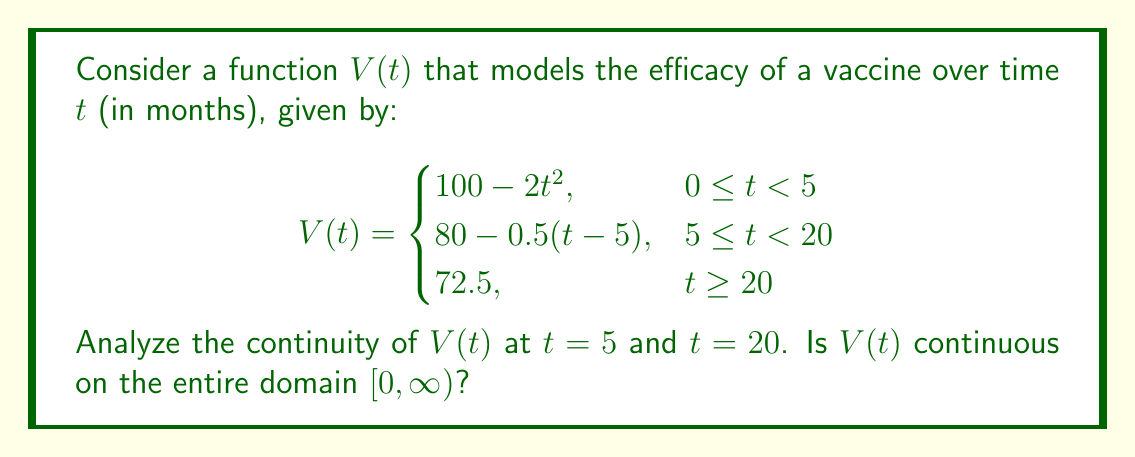Show me your answer to this math problem. To analyze the continuity of $V(t)$, we need to check for continuity at the points where the function definition changes: $t = 5$ and $t = 20$. We'll also need to consider the continuity within each piece of the function.

1. Continuity at $t = 5$:
   To be continuous at $t = 5$, we need:
   $\lim_{t \to 5^-} V(t) = \lim_{t \to 5^+} V(t) = V(5)$

   Left-hand limit: $\lim_{t \to 5^-} V(t) = 100 - 2(5)^2 = 50$
   Right-hand limit: $\lim_{t \to 5^+} V(t) = 80 - 0.5(5-5) = 80$
   Function value: $V(5) = 80 - 0.5(5-5) = 80$

   The left-hand limit doesn't equal the right-hand limit, so $V(t)$ is not continuous at $t = 5$.

2. Continuity at $t = 20$:
   Left-hand limit: $\lim_{t \to 20^-} V(t) = 80 - 0.5(20-5) = 72.5$
   Right-hand limit: $\lim_{t \to 20^+} V(t) = 72.5$
   Function value: $V(20) = 72.5$

   All three values are equal, so $V(t)$ is continuous at $t = 20$.

3. Continuity on $[0, \infty)$:
   - On $[0, 5)$: $V(t) = 100 - 2t^2$ is continuous as it's a polynomial function.
   - On $(5, 20)$: $V(t) = 80 - 0.5(t-5)$ is continuous as it's a linear function.
   - On $[20, \infty)$: $V(t) = 72.5$ is continuous as it's a constant function.

   However, due to the discontinuity at $t = 5$, $V(t)$ is not continuous on the entire domain $[0, \infty)$.
Answer: $V(t)$ is continuous at $t = 20$ but discontinuous at $t = 5$. Therefore, $V(t)$ is not continuous on the entire domain $[0, \infty)$. 